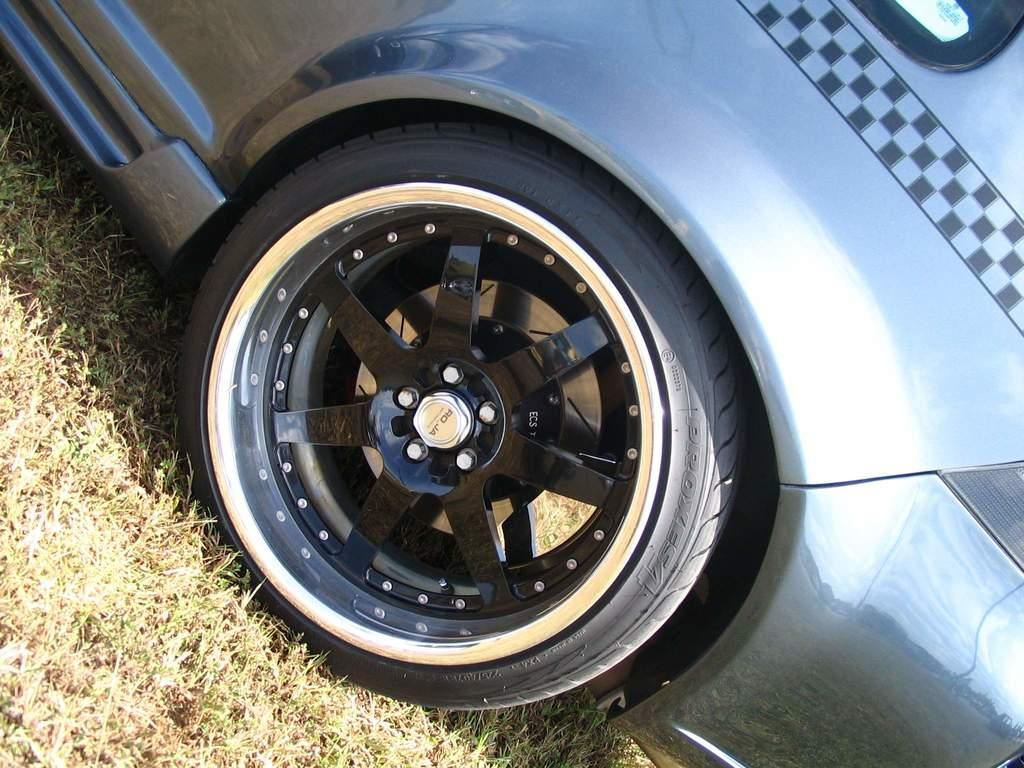What is the main subject of the image? The main subject of the image is a car. Where is the car located in the image? The car is on the grass in the image. What is the flavor of the eggs in the image? There are no eggs present in the image. 